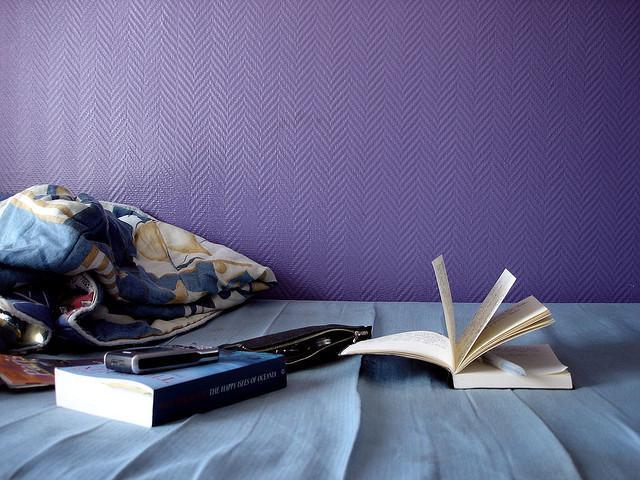How many books are in the photo?
Give a very brief answer. 2. 